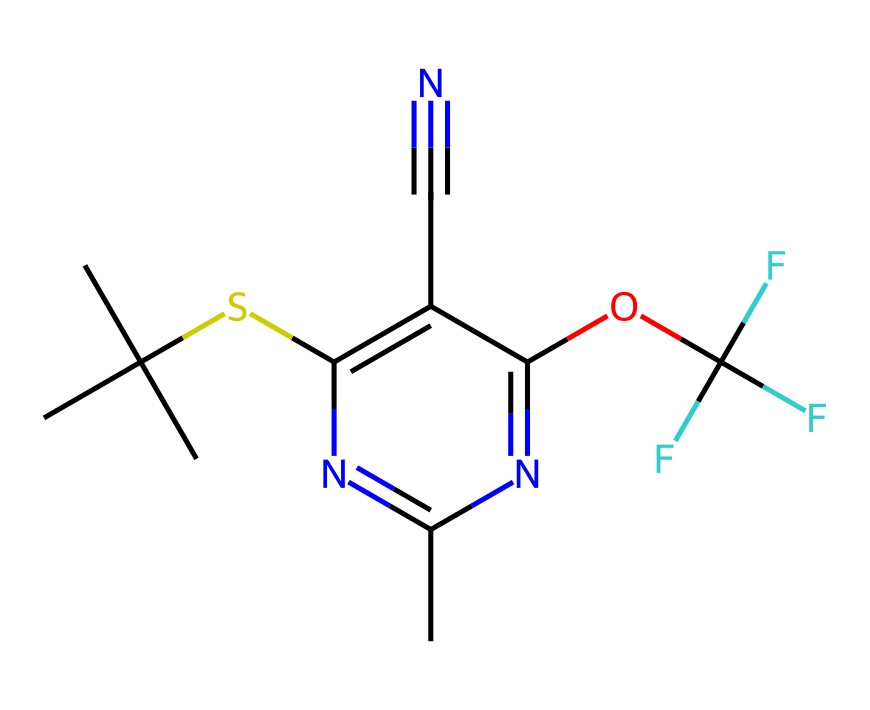What is the molecular formula of fipronil? The molecular formula can be derived by counting the number of each type of atom present in the SMILES representation. From the SMILES, the counts are: Carbon (C) = 12, Hydrogen (H) = 14, Nitrogen (N) = 4, Oxygen (O) = 1, and Sulfur (S) = 1. The resulting molecular formula is C12H14N4O2S.
Answer: C12H14N4O2S How many nitrogen atoms are present in fipronil? By inspecting the SMILES, we can identify the nitrogen atoms denoted by 'N'. There are four occurrences of 'N' in the chemical structure.
Answer: 4 What type of chemical bonds are present in fipronil? The SMILES representation indicates several types of bonds including single bonds, double bonds (indicated by '='), and a triple bond (indicated by '#'). This chemical has various bonds forming rings and connections between atoms.
Answer: single, double, triple How does fipronil affect cockroaches? Fipronil acts as a neurotoxin that disrupts the normal functioning of the insect's central nervous system. It inhibits neurotransmission by blocking neurotransmitter receptors. This effect leads to paralysis and death in cockroaches.
Answer: neurotoxin What functional group is present in fipronil that contributes to its insecticidal properties? The presence of the sulfonamide functional group (-S-) in fipronil plays a key role in its mode of action as an insecticide. This structure facilitates interference with the insect's neurophysiology, maximizing toxicity.
Answer: sulfonamide How many chiral centers does fipronil have? A chiral center is a carbon atom attached to four different groups. In the given structure, by examining the carbon atoms connected to distinct groups, we can identify that fipronil has one chiral center.
Answer: 1 